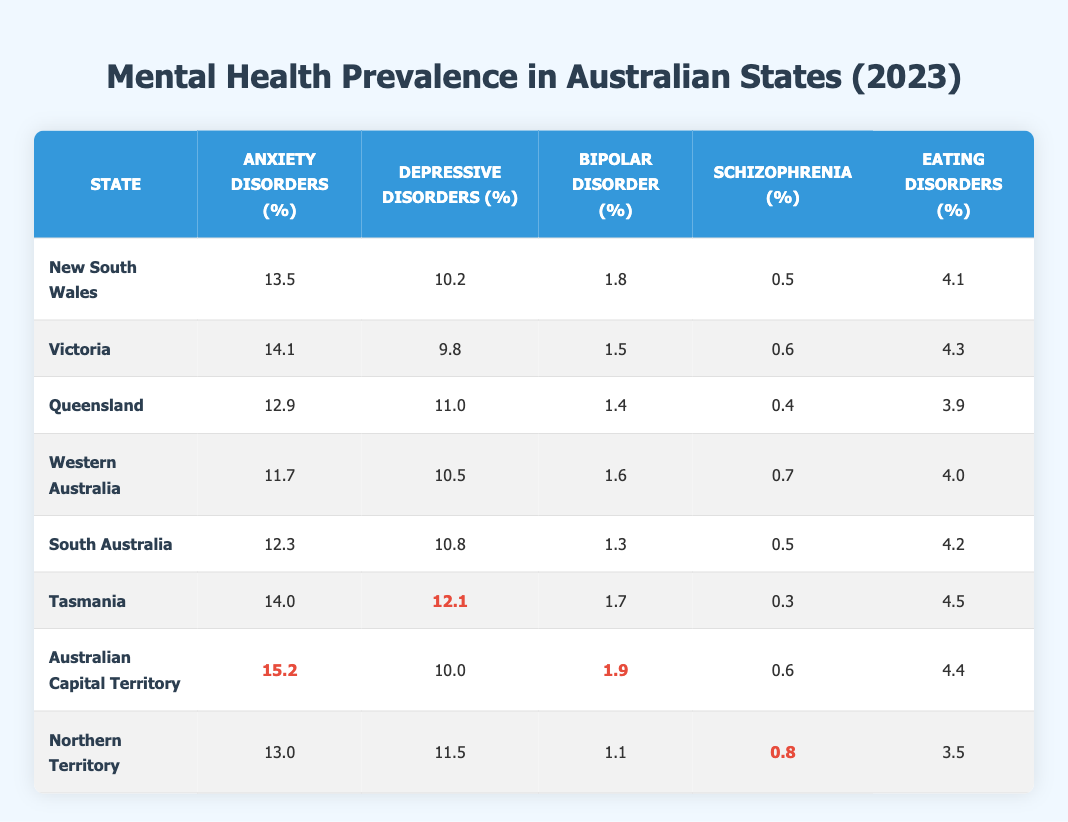What is the prevalence of anxiety disorders in New South Wales? From the table, New South Wales has a prevalence of 13.5% for anxiety disorders, as indicated in the corresponding row under the Anxiety Disorders column.
Answer: 13.5% Which state has the highest prevalence of depressive disorders? By comparing all states in the Depressive Disorders column, Tasmania has the highest prevalence at 12.1%, which is greater than all other states listed.
Answer: Tasmania What is the average prevalence of bipolar disorder across all states? The prevalence values for bipolar disorder are 1.8, 1.5, 1.4, 1.6, 1.3, 1.7, 1.9, and 1.1. Adding these gives a total of 11.3. There are 8 states, so the average is 11.3/8 = 1.4125, which rounds to 1.4 when considering the first decimal place.
Answer: 1.4 Is the prevalence of eating disorders in the Australian Capital Territory higher than in Tasmania? The prevalence for eating disorders in Australian Capital Territory is 4.4%, and in Tasmania, it is 4.5%. Since 4.4% is less than 4.5%, the statement is false.
Answer: No Which state has the lowest prevalence of schizophrenia? Looking at the Schizophrenia column, the lowest value is 0.3%, which corresponds to Tasmania, indicating that this state has the least prevalence of schizophrenia among all the states.
Answer: Tasmania How does the prevalence of anxiety disorders in Queensland compare to that in Victoria? Queensland has a prevalence of 12.9% for anxiety disorders while Victoria has 14.1%. Since 12.9% is less than 14.1%, anxiety disorders are less prevalent in Queensland than in Victoria.
Answer: Less What is the difference in prevalence of depressive disorders between New South Wales and Northern Territory? In New South Wales, the prevalence of depressive disorders is 10.2% and for Northern Territory, it is 11.5%. The difference is calculated as 11.5 - 10.2 = 1.3%.
Answer: 1.3% Are the anxiety disorders more prevalent in the Australian Capital Territory compared to Western Australia? The prevalence in Australian Capital Territory is 15.2% while in Western Australia it is 11.7%. Since 15.2% is greater than 11.7%, this statement is true.
Answer: Yes 